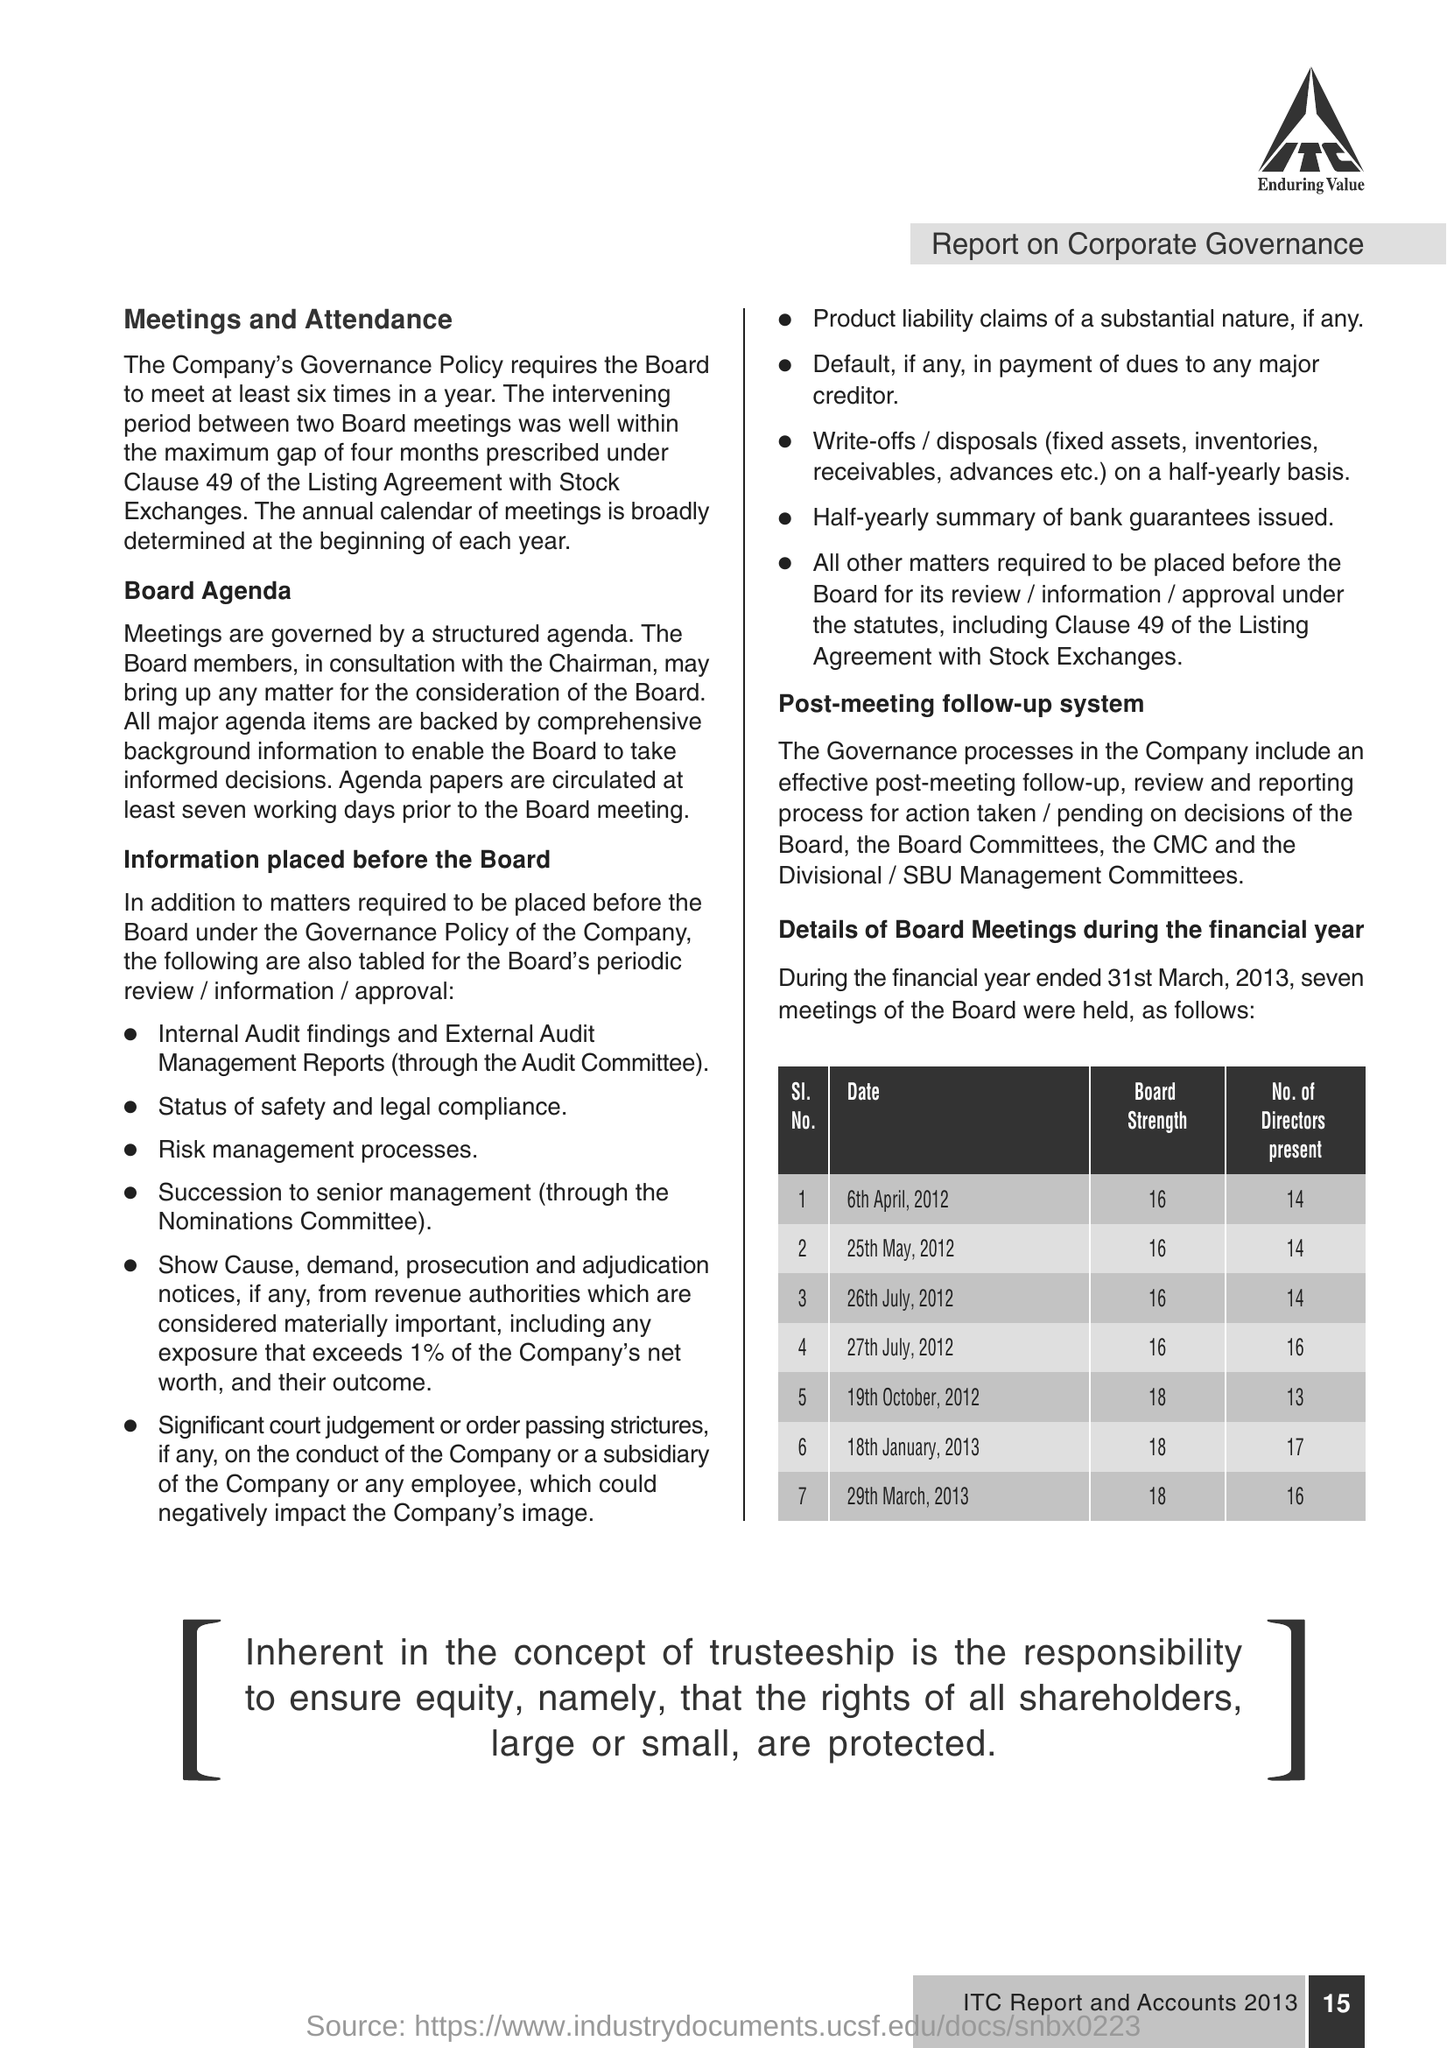List a handful of essential elements in this visual. On April 6th, 2012, there were 14 Directors present at the board meeting. 